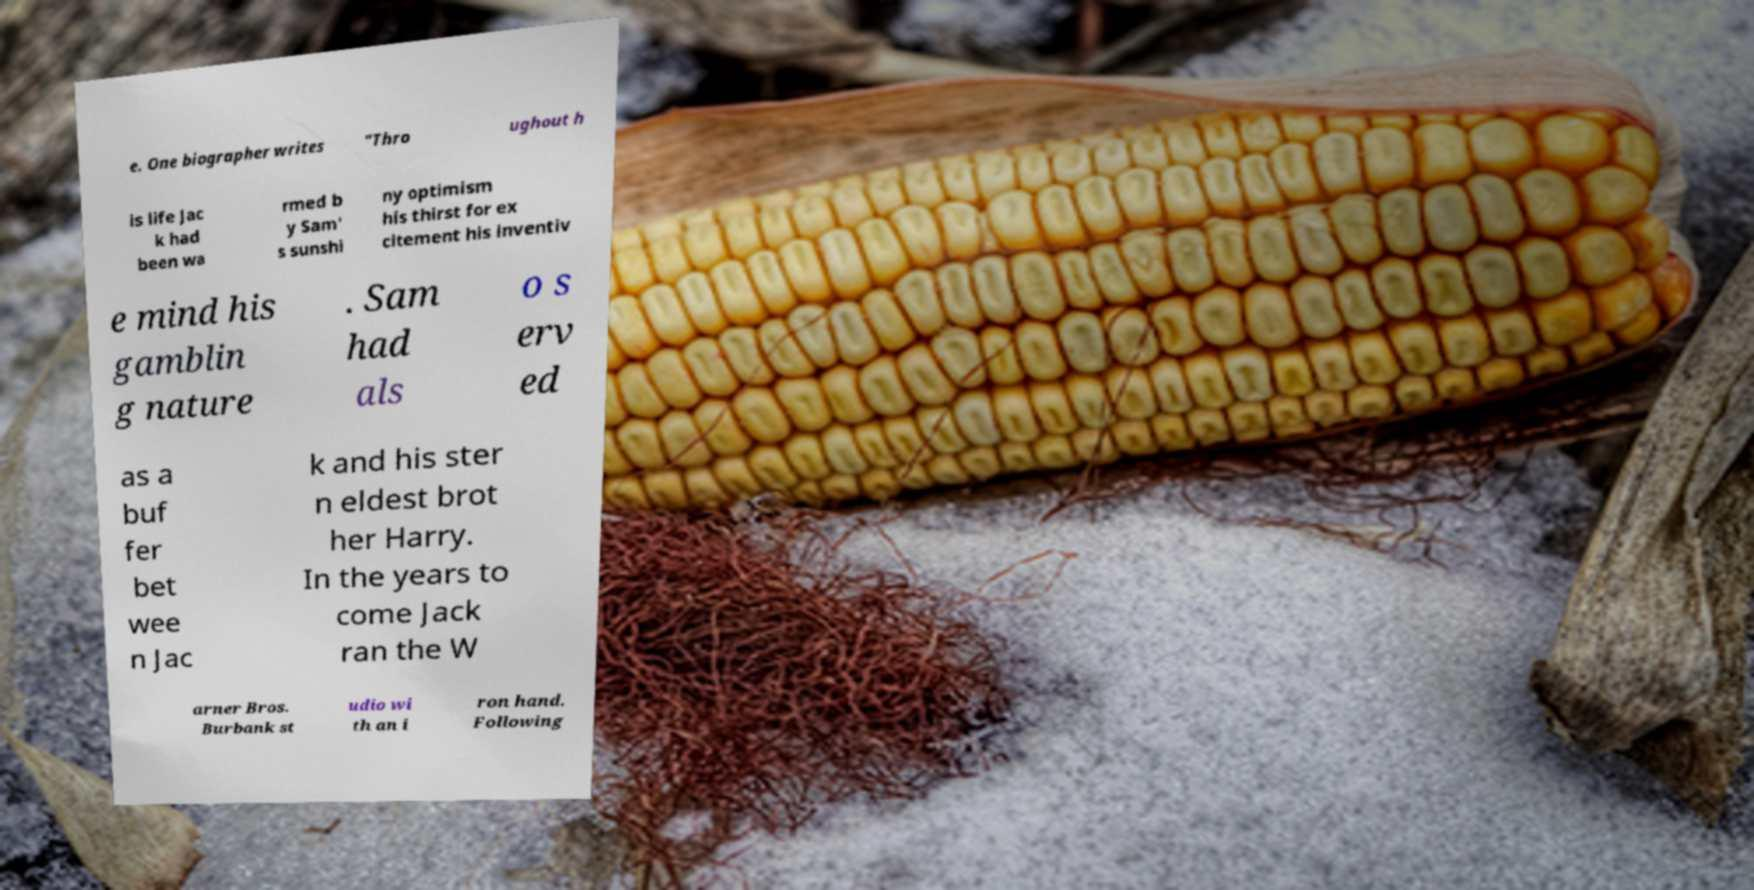Could you extract and type out the text from this image? e. One biographer writes "Thro ughout h is life Jac k had been wa rmed b y Sam' s sunshi ny optimism his thirst for ex citement his inventiv e mind his gamblin g nature . Sam had als o s erv ed as a buf fer bet wee n Jac k and his ster n eldest brot her Harry. In the years to come Jack ran the W arner Bros. Burbank st udio wi th an i ron hand. Following 